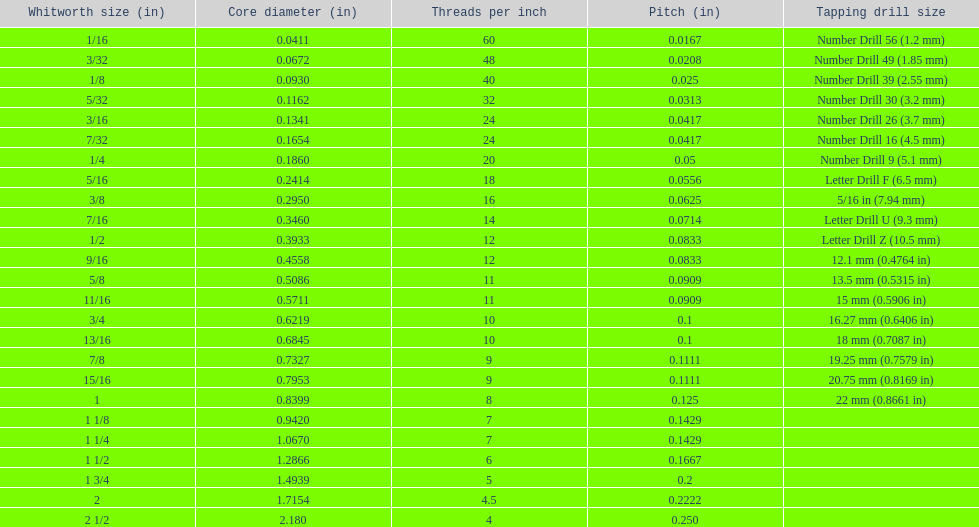Which core diameter (in) succeeds 0.1162. 